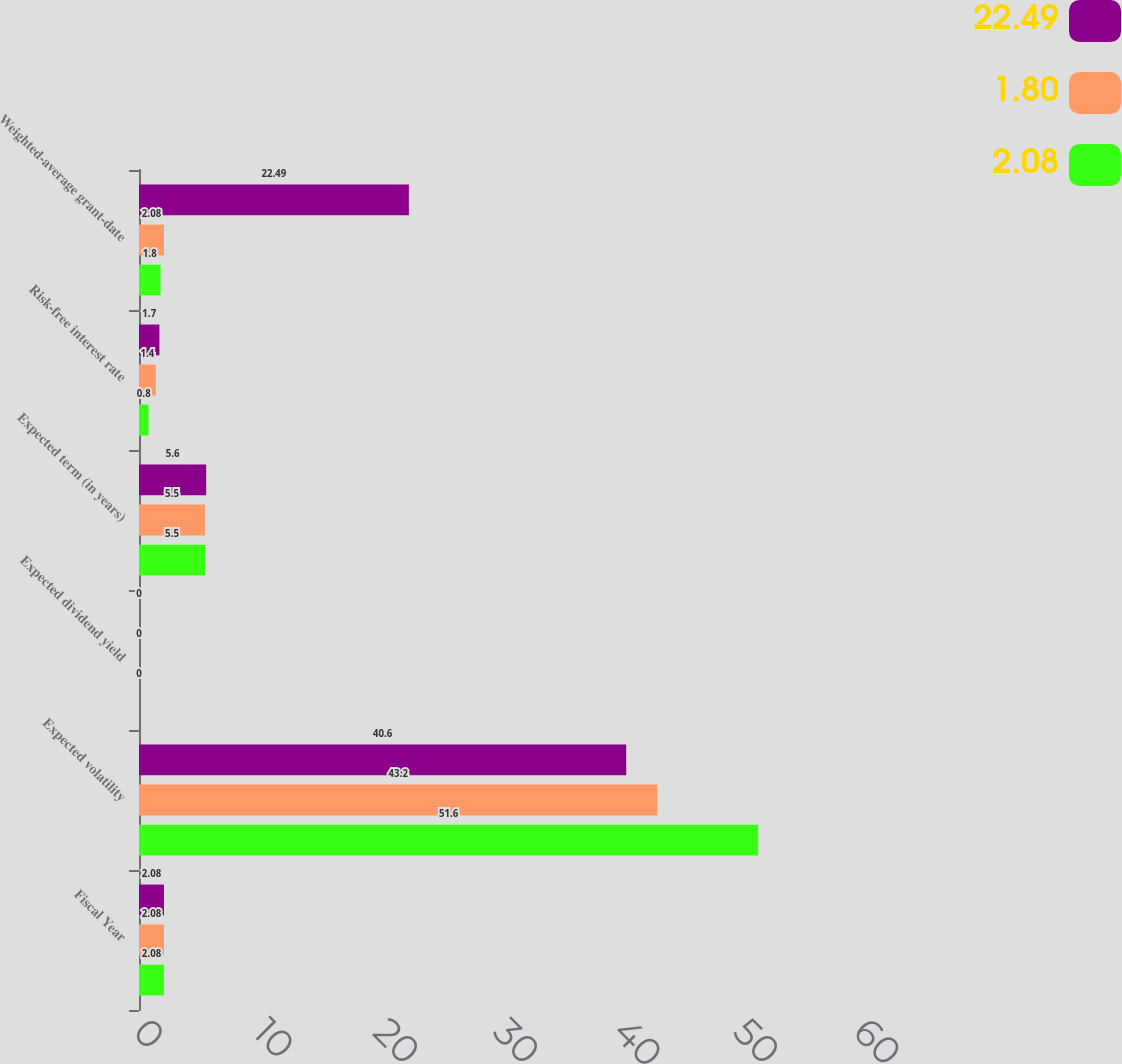<chart> <loc_0><loc_0><loc_500><loc_500><stacked_bar_chart><ecel><fcel>Fiscal Year<fcel>Expected volatility<fcel>Expected dividend yield<fcel>Expected term (in years)<fcel>Risk-free interest rate<fcel>Weighted-average grant-date<nl><fcel>22.49<fcel>2.08<fcel>40.6<fcel>0<fcel>5.6<fcel>1.7<fcel>22.49<nl><fcel>1.8<fcel>2.08<fcel>43.2<fcel>0<fcel>5.5<fcel>1.4<fcel>2.08<nl><fcel>2.08<fcel>2.08<fcel>51.6<fcel>0<fcel>5.5<fcel>0.8<fcel>1.8<nl></chart> 